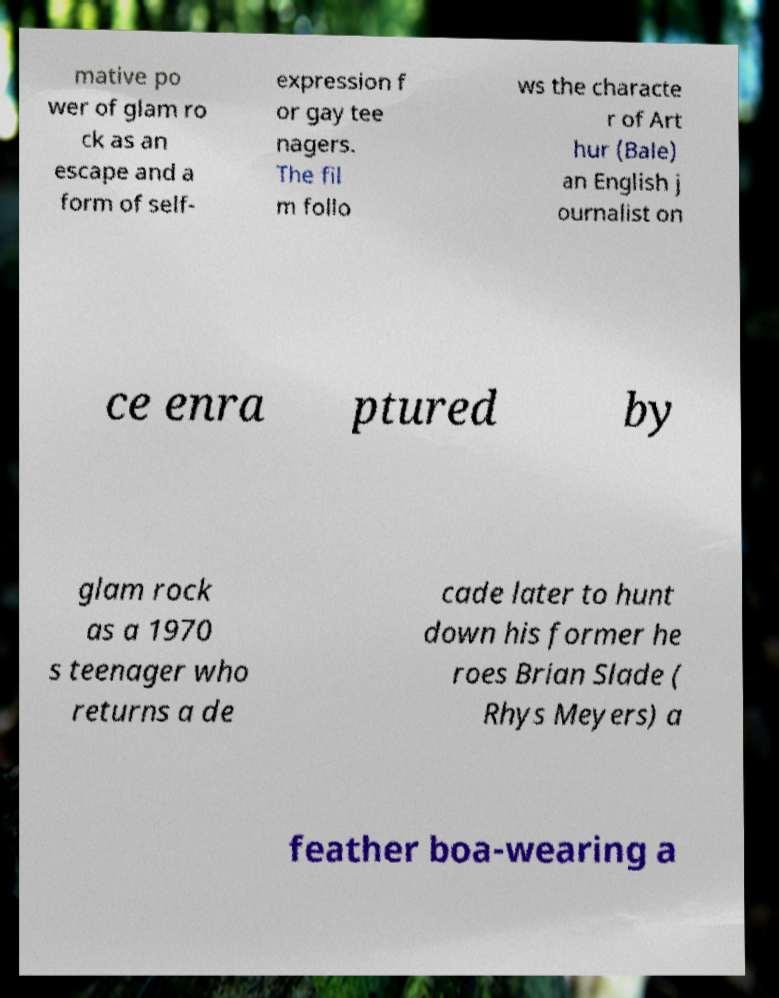There's text embedded in this image that I need extracted. Can you transcribe it verbatim? mative po wer of glam ro ck as an escape and a form of self- expression f or gay tee nagers. The fil m follo ws the characte r of Art hur (Bale) an English j ournalist on ce enra ptured by glam rock as a 1970 s teenager who returns a de cade later to hunt down his former he roes Brian Slade ( Rhys Meyers) a feather boa-wearing a 